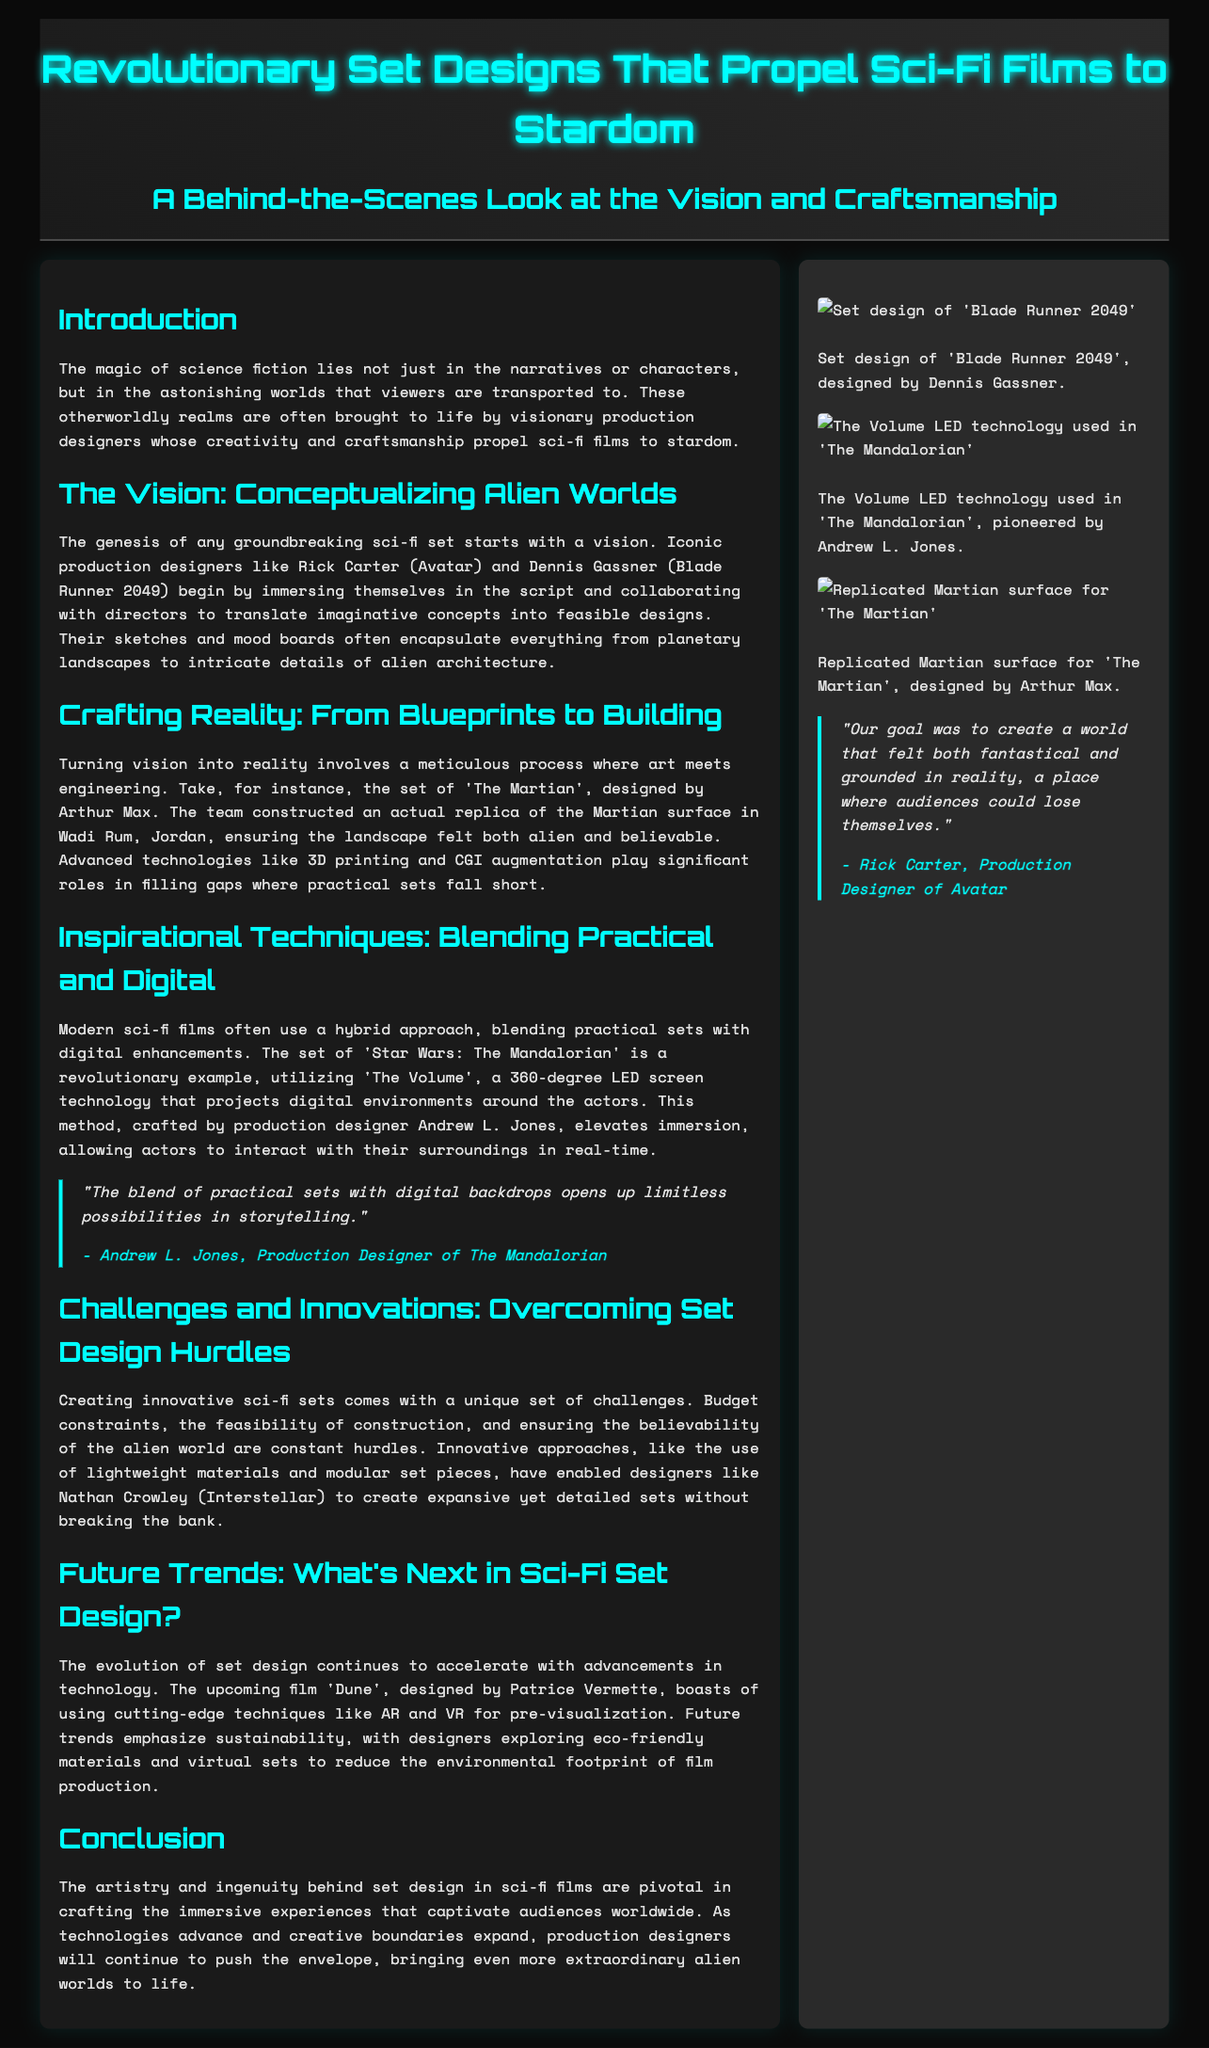what is the title of the article? The title of the article is presented at the top of the document, highlighting its main focus.
Answer: Revolutionary Set Designs That Propel Sci-Fi Films to Stardom who designed the set for Avatar? The document mentions Rick Carter as the production designer for Avatar in the section discussing conceptualizing alien worlds.
Answer: Rick Carter what technology is used in 'The Mandalorian'? The sidebar discusses 'The Volume', a 360-degree LED screen technology used in 'The Mandalorian'.
Answer: The Volume which film's set was constructed in Wadi Rum, Jordan? The section on crafting reality specifically mentions 'The Martian' and its set being created in Wadi Rum, Jordan.
Answer: The Martian who is the production designer of 'Interstellar'? The document identifies Nathan Crowley as the production designer for 'Interstellar' in the context of set design challenges.
Answer: Nathan Crowley what is a key trend for future sci-fi set design mentioned? In the section on future trends, the document emphasizes sustainability as a key trend.
Answer: Sustainability how does Andrew L. Jones describe the combination of practical sets and digital backdrops? A quote from Andrew L. Jones highlights the potential of blending practical and digital environments in storytelling.
Answer: Limitless possibilities what color scheme is used for the header background? The header background features a gradient, which is described in the style section of the document.
Answer: Dark gradient how is the main content area styled? The main content area is detailed as having a specific background color, padding, and box shadow in the style section.
Answer: Dark background with padding and shadow 